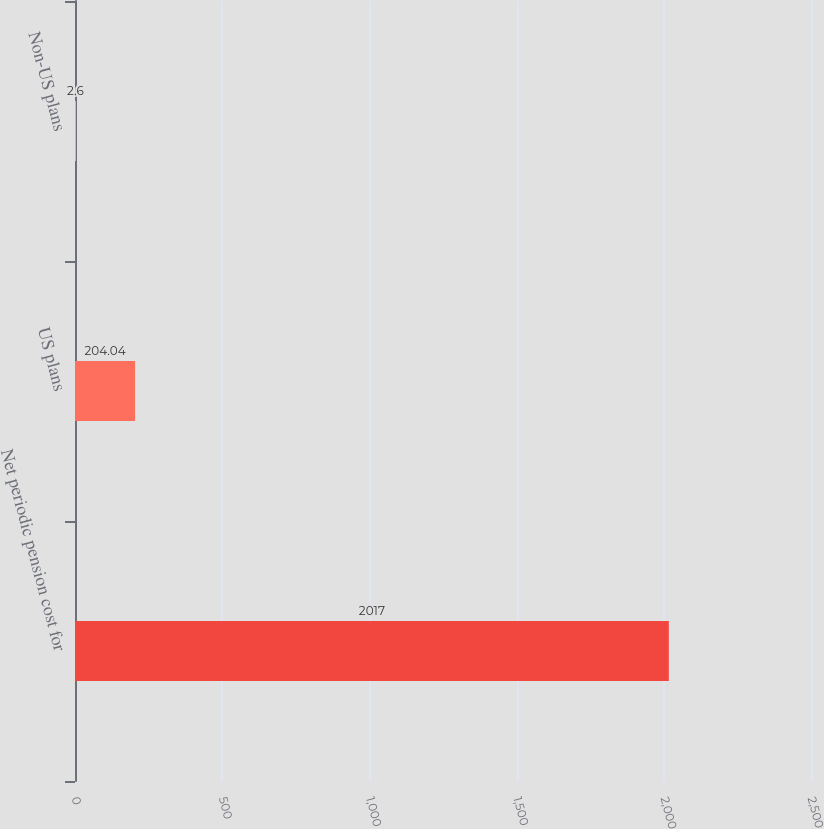Convert chart to OTSL. <chart><loc_0><loc_0><loc_500><loc_500><bar_chart><fcel>Net periodic pension cost for<fcel>US plans<fcel>Non-US plans<nl><fcel>2017<fcel>204.04<fcel>2.6<nl></chart> 